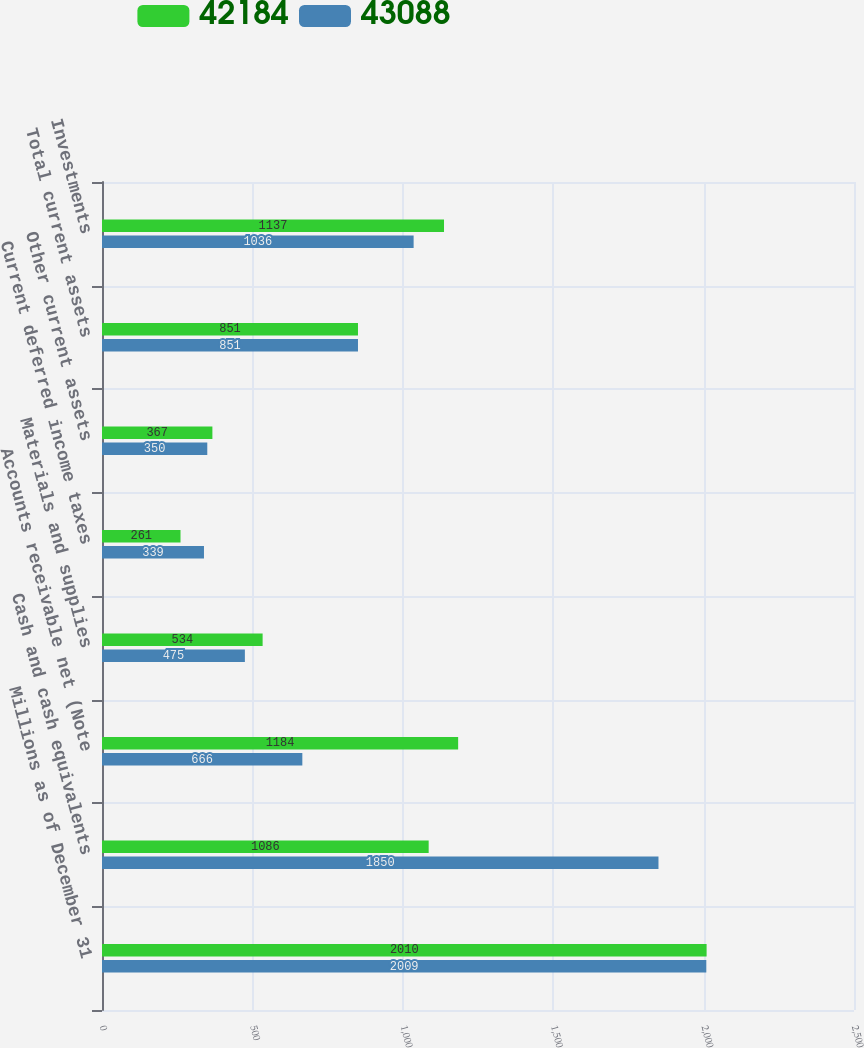Convert chart. <chart><loc_0><loc_0><loc_500><loc_500><stacked_bar_chart><ecel><fcel>Millions as of December 31<fcel>Cash and cash equivalents<fcel>Accounts receivable net (Note<fcel>Materials and supplies<fcel>Current deferred income taxes<fcel>Other current assets<fcel>Total current assets<fcel>Investments<nl><fcel>42184<fcel>2010<fcel>1086<fcel>1184<fcel>534<fcel>261<fcel>367<fcel>851<fcel>1137<nl><fcel>43088<fcel>2009<fcel>1850<fcel>666<fcel>475<fcel>339<fcel>350<fcel>851<fcel>1036<nl></chart> 